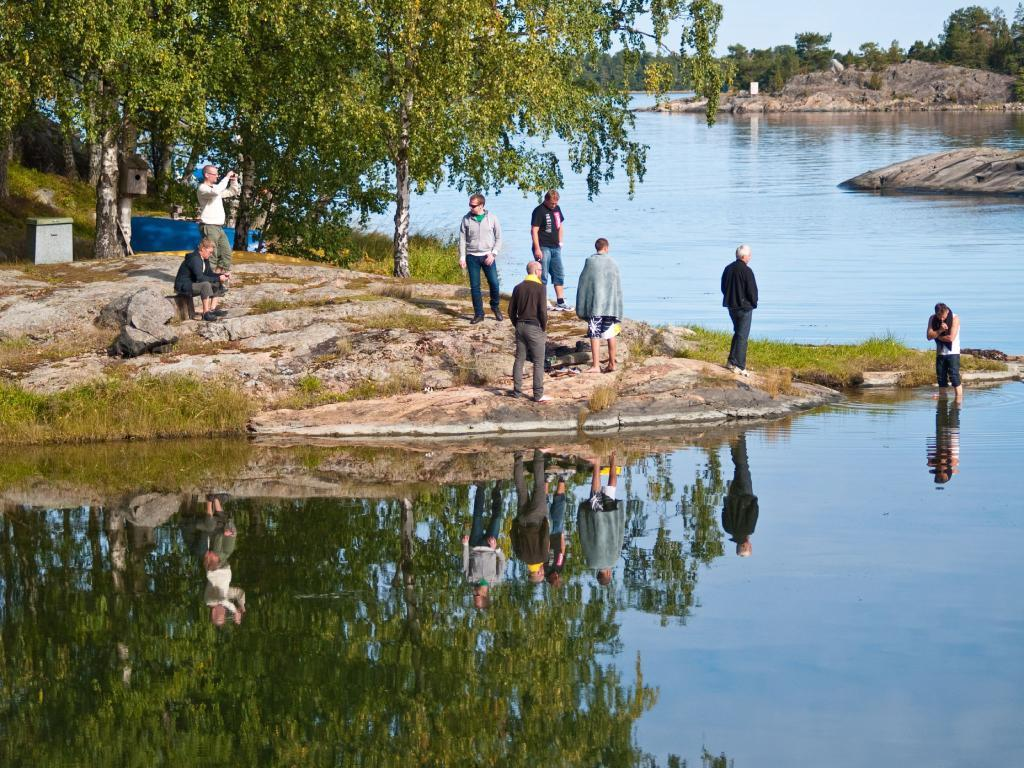What is the main element present in the image? There is water in the image. What type of vegetation can be seen in the image? There is grass in the image. Are there any natural features present in the image? Yes, there are rocks in the image. Can you describe the people in the image? There is a group of people in the image. What can be seen in the background of the image? There are boxes, an inflatable boat, and trees in the background of the image. What type of floor can be seen in the image? There is no floor visible in the image; it primarily features water, grass, and rocks. 